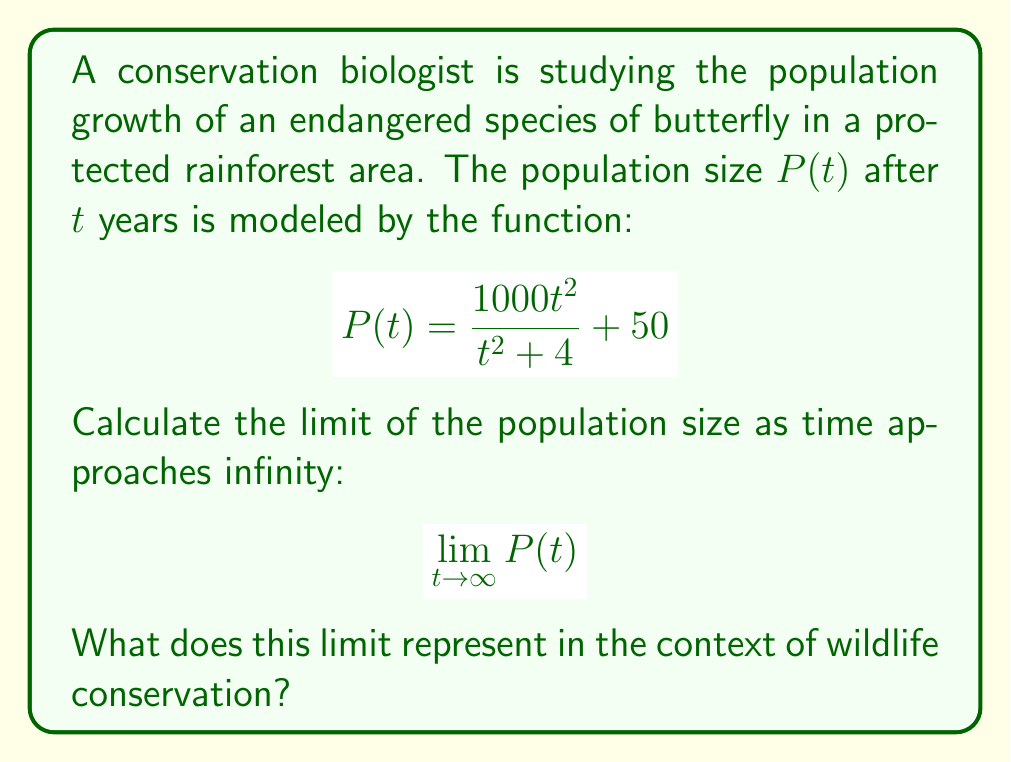Show me your answer to this math problem. Let's approach this step-by-step:

1) First, we need to evaluate the limit:
   $$\lim_{t \to \infty} P(t) = \lim_{t \to \infty} \left(\frac{1000t^2}{t^2 + 4} + 50\right)$$

2) We can split this limit:
   $$\lim_{t \to \infty} \frac{1000t^2}{t^2 + 4} + \lim_{t \to \infty} 50$$

3) The second limit is simply 50. For the first limit:
   $$\lim_{t \to \infty} \frac{1000t^2}{t^2 + 4} = 1000 \cdot \lim_{t \to \infty} \frac{t^2}{t^2 + 4}$$

4) To evaluate this, divide both numerator and denominator by $t^2$:
   $$1000 \cdot \lim_{t \to \infty} \frac{1}{1 + \frac{4}{t^2}}$$

5) As $t$ approaches infinity, $\frac{4}{t^2}$ approaches 0:
   $$1000 \cdot \frac{1}{1 + 0} = 1000$$

6) Adding this to the 50 from step 2:
   $$1000 + 50 = 1050$$

In the context of wildlife conservation, this limit represents the carrying capacity of the environment for this butterfly species. It suggests that under the current conditions in the protected rainforest area, the population will stabilize at around 1050 butterflies in the long term. This information is crucial for conservationists to assess the health of the population and the effectiveness of their protection efforts.
Answer: 1050; represents the carrying capacity of the environment for the butterfly species. 